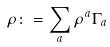Convert formula to latex. <formula><loc_0><loc_0><loc_500><loc_500>\rho \colon = { \sum _ { a } } \, \rho ^ { a } \Gamma _ { a }</formula> 